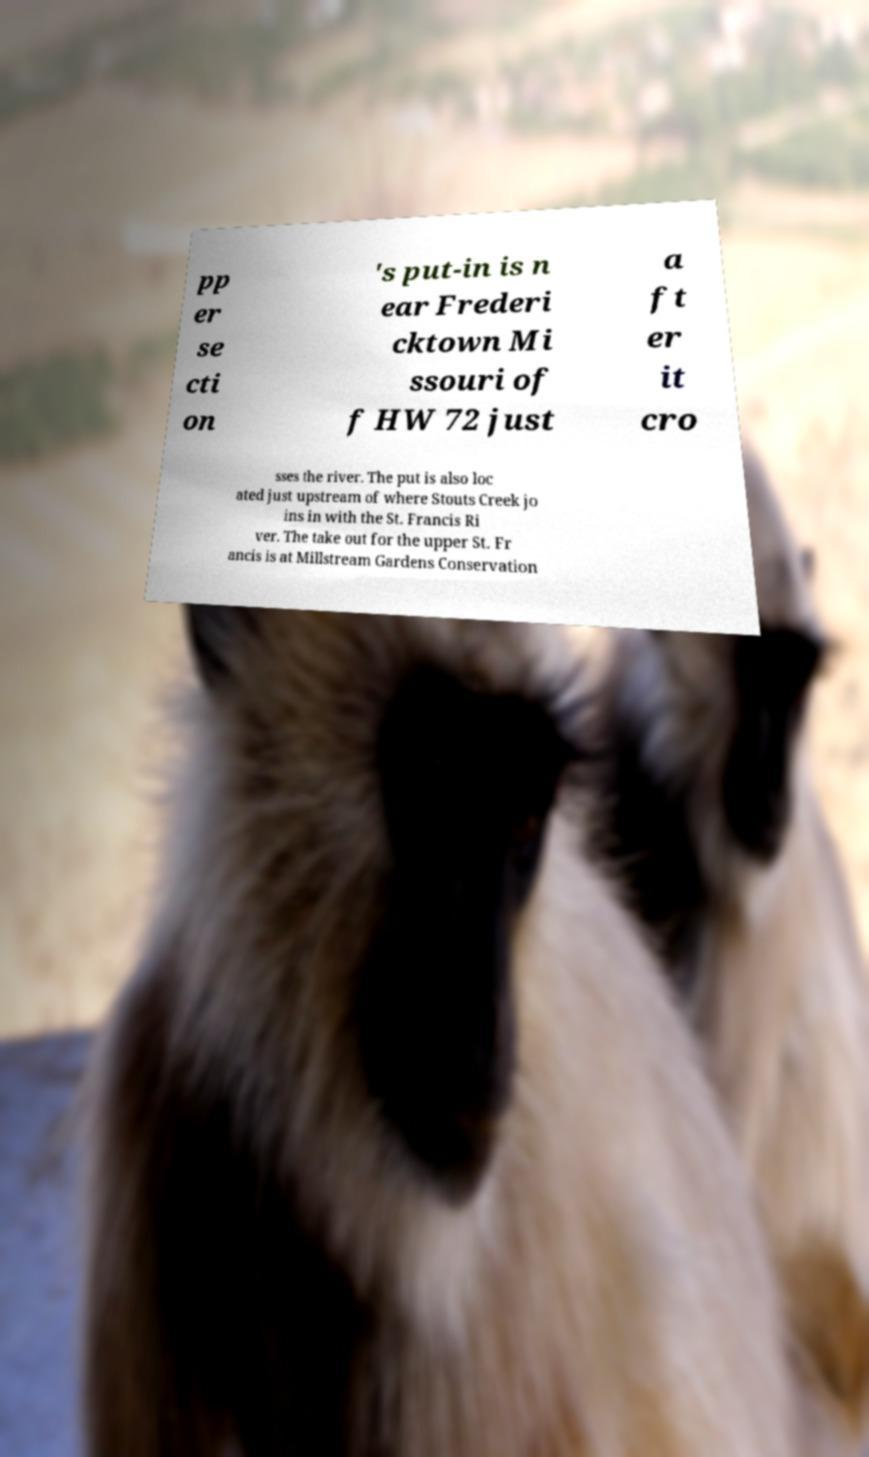Please read and relay the text visible in this image. What does it say? pp er se cti on 's put-in is n ear Frederi cktown Mi ssouri of f HW 72 just a ft er it cro sses the river. The put is also loc ated just upstream of where Stouts Creek jo ins in with the St. Francis Ri ver. The take out for the upper St. Fr ancis is at Millstream Gardens Conservation 